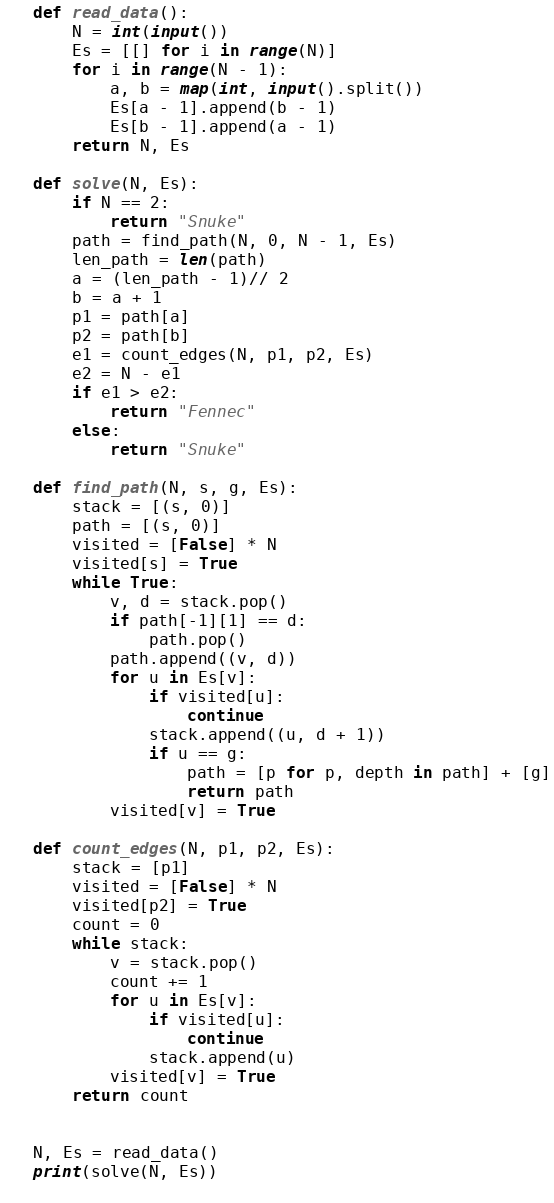Convert code to text. <code><loc_0><loc_0><loc_500><loc_500><_Python_>
def read_data():
    N = int(input())
    Es = [[] for i in range(N)]
    for i in range(N - 1):
        a, b = map(int, input().split())
        Es[a - 1].append(b - 1)
        Es[b - 1].append(a - 1)
    return N, Es

def solve(N, Es):
    if N == 2:
        return "Snuke"
    path = find_path(N, 0, N - 1, Es)
    len_path = len(path)
    a = (len_path - 1)// 2
    b = a + 1
    p1 = path[a]
    p2 = path[b]
    e1 = count_edges(N, p1, p2, Es)
    e2 = N - e1
    if e1 > e2:
        return "Fennec"
    else:
        return "Snuke"

def find_path(N, s, g, Es):
    stack = [(s, 0)]
    path = [(s, 0)]
    visited = [False] * N
    visited[s] = True
    while True:
        v, d = stack.pop()
        if path[-1][1] == d:
            path.pop()
        path.append((v, d))
        for u in Es[v]:
            if visited[u]:
                continue
            stack.append((u, d + 1))
            if u == g:
                path = [p for p, depth in path] + [g]
                return path
        visited[v] = True

def count_edges(N, p1, p2, Es):
    stack = [p1]
    visited = [False] * N
    visited[p2] = True
    count = 0
    while stack:
        v = stack.pop()
        count += 1
        for u in Es[v]:
            if visited[u]:
                continue
            stack.append(u)
        visited[v] = True
    return count


N, Es = read_data()
print(solve(N, Es))
    </code> 